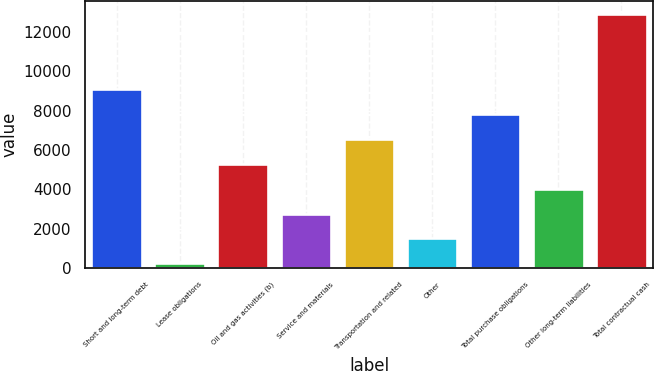<chart> <loc_0><loc_0><loc_500><loc_500><bar_chart><fcel>Short and long-term debt<fcel>Lease obligations<fcel>Oil and gas activities (b)<fcel>Service and materials<fcel>Transportation and related<fcel>Other<fcel>Total purchase obligations<fcel>Other long-term liabilities<fcel>Total contractual cash<nl><fcel>9102.6<fcel>235<fcel>5302.2<fcel>2768.6<fcel>6569<fcel>1501.8<fcel>7835.8<fcel>4035.4<fcel>12903<nl></chart> 